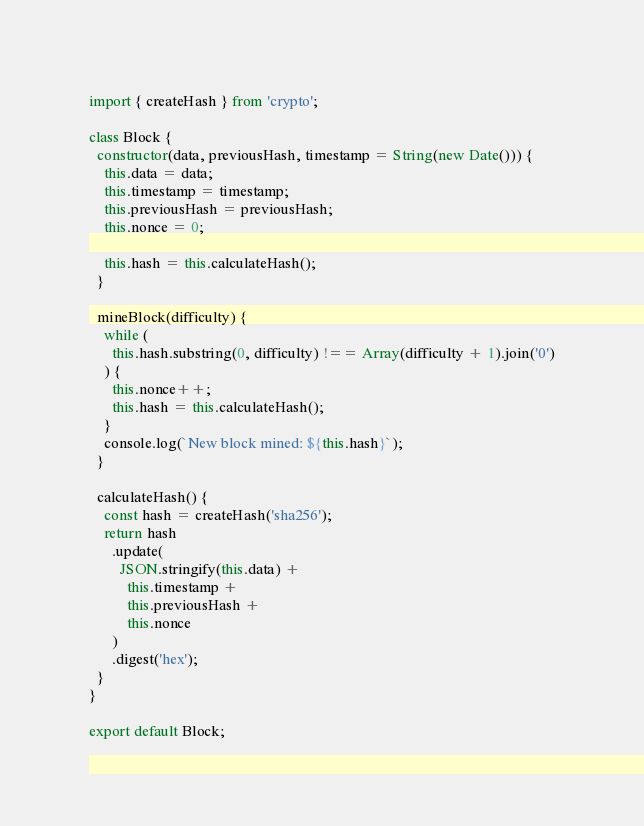<code> <loc_0><loc_0><loc_500><loc_500><_JavaScript_>import { createHash } from 'crypto';

class Block {
  constructor(data, previousHash, timestamp = String(new Date())) {
    this.data = data;
    this.timestamp = timestamp;
    this.previousHash = previousHash;
    this.nonce = 0;

    this.hash = this.calculateHash();
  }

  mineBlock(difficulty) {
    while (
      this.hash.substring(0, difficulty) !== Array(difficulty + 1).join('0')
    ) {
      this.nonce++;
      this.hash = this.calculateHash();
    }
    console.log(`New block mined: ${this.hash}`);
  }

  calculateHash() {
    const hash = createHash('sha256');
    return hash
      .update(
        JSON.stringify(this.data) +
          this.timestamp +
          this.previousHash +
          this.nonce
      )
      .digest('hex');
  }
}

export default Block;
</code> 